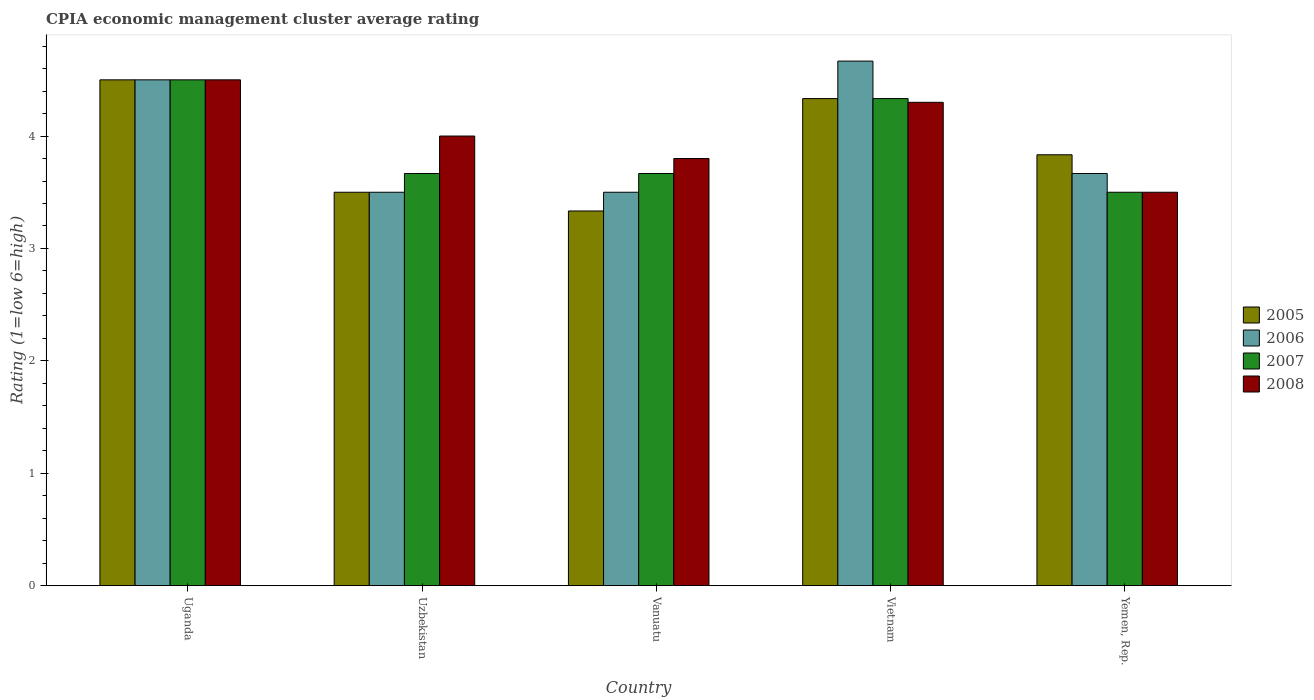How many groups of bars are there?
Offer a terse response. 5. Are the number of bars on each tick of the X-axis equal?
Keep it short and to the point. Yes. What is the label of the 2nd group of bars from the left?
Ensure brevity in your answer.  Uzbekistan. In how many cases, is the number of bars for a given country not equal to the number of legend labels?
Offer a terse response. 0. Across all countries, what is the minimum CPIA rating in 2008?
Provide a short and direct response. 3.5. In which country was the CPIA rating in 2005 maximum?
Keep it short and to the point. Uganda. In which country was the CPIA rating in 2006 minimum?
Give a very brief answer. Uzbekistan. What is the total CPIA rating in 2006 in the graph?
Provide a short and direct response. 19.83. What is the difference between the CPIA rating in 2008 in Vanuatu and the CPIA rating in 2006 in Uganda?
Provide a short and direct response. -0.7. What is the average CPIA rating in 2005 per country?
Provide a succinct answer. 3.9. What is the difference between the CPIA rating of/in 2006 and CPIA rating of/in 2007 in Uzbekistan?
Keep it short and to the point. -0.17. What is the ratio of the CPIA rating in 2005 in Uganda to that in Uzbekistan?
Your answer should be compact. 1.29. Is the difference between the CPIA rating in 2006 in Uganda and Vanuatu greater than the difference between the CPIA rating in 2007 in Uganda and Vanuatu?
Provide a succinct answer. Yes. What is the difference between the highest and the second highest CPIA rating in 2005?
Your answer should be compact. -0.67. What is the difference between the highest and the lowest CPIA rating in 2006?
Keep it short and to the point. 1.17. Is it the case that in every country, the sum of the CPIA rating in 2007 and CPIA rating in 2008 is greater than the sum of CPIA rating in 2005 and CPIA rating in 2006?
Your response must be concise. No. What does the 4th bar from the left in Vanuatu represents?
Your answer should be very brief. 2008. What does the 3rd bar from the right in Uzbekistan represents?
Give a very brief answer. 2006. Is it the case that in every country, the sum of the CPIA rating in 2008 and CPIA rating in 2006 is greater than the CPIA rating in 2005?
Offer a terse response. Yes. Are all the bars in the graph horizontal?
Ensure brevity in your answer.  No. How many countries are there in the graph?
Offer a terse response. 5. What is the difference between two consecutive major ticks on the Y-axis?
Ensure brevity in your answer.  1. How many legend labels are there?
Your answer should be very brief. 4. What is the title of the graph?
Your response must be concise. CPIA economic management cluster average rating. Does "1989" appear as one of the legend labels in the graph?
Offer a terse response. No. What is the label or title of the X-axis?
Your response must be concise. Country. What is the Rating (1=low 6=high) in 2005 in Uganda?
Ensure brevity in your answer.  4.5. What is the Rating (1=low 6=high) in 2006 in Uganda?
Keep it short and to the point. 4.5. What is the Rating (1=low 6=high) of 2007 in Uzbekistan?
Ensure brevity in your answer.  3.67. What is the Rating (1=low 6=high) in 2008 in Uzbekistan?
Make the answer very short. 4. What is the Rating (1=low 6=high) of 2005 in Vanuatu?
Your response must be concise. 3.33. What is the Rating (1=low 6=high) in 2006 in Vanuatu?
Provide a succinct answer. 3.5. What is the Rating (1=low 6=high) of 2007 in Vanuatu?
Keep it short and to the point. 3.67. What is the Rating (1=low 6=high) in 2005 in Vietnam?
Ensure brevity in your answer.  4.33. What is the Rating (1=low 6=high) in 2006 in Vietnam?
Ensure brevity in your answer.  4.67. What is the Rating (1=low 6=high) of 2007 in Vietnam?
Offer a very short reply. 4.33. What is the Rating (1=low 6=high) of 2005 in Yemen, Rep.?
Keep it short and to the point. 3.83. What is the Rating (1=low 6=high) of 2006 in Yemen, Rep.?
Provide a short and direct response. 3.67. What is the Rating (1=low 6=high) in 2008 in Yemen, Rep.?
Offer a terse response. 3.5. Across all countries, what is the maximum Rating (1=low 6=high) in 2005?
Your answer should be compact. 4.5. Across all countries, what is the maximum Rating (1=low 6=high) of 2006?
Make the answer very short. 4.67. Across all countries, what is the maximum Rating (1=low 6=high) in 2007?
Offer a very short reply. 4.5. Across all countries, what is the minimum Rating (1=low 6=high) in 2005?
Your response must be concise. 3.33. Across all countries, what is the minimum Rating (1=low 6=high) in 2007?
Offer a terse response. 3.5. Across all countries, what is the minimum Rating (1=low 6=high) of 2008?
Your answer should be compact. 3.5. What is the total Rating (1=low 6=high) of 2005 in the graph?
Provide a short and direct response. 19.5. What is the total Rating (1=low 6=high) in 2006 in the graph?
Offer a terse response. 19.83. What is the total Rating (1=low 6=high) in 2007 in the graph?
Your answer should be very brief. 19.67. What is the total Rating (1=low 6=high) in 2008 in the graph?
Offer a very short reply. 20.1. What is the difference between the Rating (1=low 6=high) of 2006 in Uganda and that in Uzbekistan?
Offer a very short reply. 1. What is the difference between the Rating (1=low 6=high) of 2008 in Uganda and that in Uzbekistan?
Provide a short and direct response. 0.5. What is the difference between the Rating (1=low 6=high) of 2008 in Uganda and that in Vanuatu?
Keep it short and to the point. 0.7. What is the difference between the Rating (1=low 6=high) of 2007 in Uganda and that in Yemen, Rep.?
Your answer should be compact. 1. What is the difference between the Rating (1=low 6=high) of 2007 in Uzbekistan and that in Vanuatu?
Provide a short and direct response. 0. What is the difference between the Rating (1=low 6=high) in 2008 in Uzbekistan and that in Vanuatu?
Provide a succinct answer. 0.2. What is the difference between the Rating (1=low 6=high) of 2006 in Uzbekistan and that in Vietnam?
Your response must be concise. -1.17. What is the difference between the Rating (1=low 6=high) of 2005 in Uzbekistan and that in Yemen, Rep.?
Keep it short and to the point. -0.33. What is the difference between the Rating (1=low 6=high) of 2005 in Vanuatu and that in Vietnam?
Provide a short and direct response. -1. What is the difference between the Rating (1=low 6=high) of 2006 in Vanuatu and that in Vietnam?
Offer a very short reply. -1.17. What is the difference between the Rating (1=low 6=high) of 2007 in Vanuatu and that in Vietnam?
Your answer should be compact. -0.67. What is the difference between the Rating (1=low 6=high) of 2008 in Vanuatu and that in Vietnam?
Your answer should be very brief. -0.5. What is the difference between the Rating (1=low 6=high) of 2005 in Vanuatu and that in Yemen, Rep.?
Ensure brevity in your answer.  -0.5. What is the difference between the Rating (1=low 6=high) in 2006 in Vanuatu and that in Yemen, Rep.?
Make the answer very short. -0.17. What is the difference between the Rating (1=low 6=high) in 2007 in Vietnam and that in Yemen, Rep.?
Provide a short and direct response. 0.83. What is the difference between the Rating (1=low 6=high) in 2008 in Vietnam and that in Yemen, Rep.?
Provide a short and direct response. 0.8. What is the difference between the Rating (1=low 6=high) of 2005 in Uganda and the Rating (1=low 6=high) of 2007 in Uzbekistan?
Give a very brief answer. 0.83. What is the difference between the Rating (1=low 6=high) of 2005 in Uganda and the Rating (1=low 6=high) of 2008 in Uzbekistan?
Give a very brief answer. 0.5. What is the difference between the Rating (1=low 6=high) of 2006 in Uganda and the Rating (1=low 6=high) of 2007 in Uzbekistan?
Ensure brevity in your answer.  0.83. What is the difference between the Rating (1=low 6=high) of 2006 in Uganda and the Rating (1=low 6=high) of 2008 in Uzbekistan?
Your answer should be compact. 0.5. What is the difference between the Rating (1=low 6=high) in 2005 in Uganda and the Rating (1=low 6=high) in 2008 in Vanuatu?
Ensure brevity in your answer.  0.7. What is the difference between the Rating (1=low 6=high) of 2006 in Uganda and the Rating (1=low 6=high) of 2007 in Vanuatu?
Your answer should be very brief. 0.83. What is the difference between the Rating (1=low 6=high) in 2005 in Uganda and the Rating (1=low 6=high) in 2006 in Yemen, Rep.?
Your answer should be very brief. 0.83. What is the difference between the Rating (1=low 6=high) in 2005 in Uganda and the Rating (1=low 6=high) in 2008 in Yemen, Rep.?
Provide a short and direct response. 1. What is the difference between the Rating (1=low 6=high) in 2007 in Uganda and the Rating (1=low 6=high) in 2008 in Yemen, Rep.?
Ensure brevity in your answer.  1. What is the difference between the Rating (1=low 6=high) of 2005 in Uzbekistan and the Rating (1=low 6=high) of 2006 in Vanuatu?
Your answer should be compact. 0. What is the difference between the Rating (1=low 6=high) of 2005 in Uzbekistan and the Rating (1=low 6=high) of 2007 in Vanuatu?
Your answer should be very brief. -0.17. What is the difference between the Rating (1=low 6=high) of 2006 in Uzbekistan and the Rating (1=low 6=high) of 2007 in Vanuatu?
Provide a succinct answer. -0.17. What is the difference between the Rating (1=low 6=high) of 2007 in Uzbekistan and the Rating (1=low 6=high) of 2008 in Vanuatu?
Offer a terse response. -0.13. What is the difference between the Rating (1=low 6=high) of 2005 in Uzbekistan and the Rating (1=low 6=high) of 2006 in Vietnam?
Offer a terse response. -1.17. What is the difference between the Rating (1=low 6=high) of 2005 in Uzbekistan and the Rating (1=low 6=high) of 2007 in Vietnam?
Ensure brevity in your answer.  -0.83. What is the difference between the Rating (1=low 6=high) in 2006 in Uzbekistan and the Rating (1=low 6=high) in 2008 in Vietnam?
Make the answer very short. -0.8. What is the difference between the Rating (1=low 6=high) in 2007 in Uzbekistan and the Rating (1=low 6=high) in 2008 in Vietnam?
Keep it short and to the point. -0.63. What is the difference between the Rating (1=low 6=high) of 2005 in Uzbekistan and the Rating (1=low 6=high) of 2006 in Yemen, Rep.?
Keep it short and to the point. -0.17. What is the difference between the Rating (1=low 6=high) in 2006 in Uzbekistan and the Rating (1=low 6=high) in 2007 in Yemen, Rep.?
Provide a short and direct response. 0. What is the difference between the Rating (1=low 6=high) of 2007 in Uzbekistan and the Rating (1=low 6=high) of 2008 in Yemen, Rep.?
Offer a terse response. 0.17. What is the difference between the Rating (1=low 6=high) in 2005 in Vanuatu and the Rating (1=low 6=high) in 2006 in Vietnam?
Keep it short and to the point. -1.33. What is the difference between the Rating (1=low 6=high) of 2005 in Vanuatu and the Rating (1=low 6=high) of 2008 in Vietnam?
Provide a short and direct response. -0.97. What is the difference between the Rating (1=low 6=high) in 2007 in Vanuatu and the Rating (1=low 6=high) in 2008 in Vietnam?
Provide a succinct answer. -0.63. What is the difference between the Rating (1=low 6=high) in 2005 in Vanuatu and the Rating (1=low 6=high) in 2006 in Yemen, Rep.?
Offer a very short reply. -0.33. What is the difference between the Rating (1=low 6=high) of 2005 in Vanuatu and the Rating (1=low 6=high) of 2008 in Yemen, Rep.?
Provide a succinct answer. -0.17. What is the difference between the Rating (1=low 6=high) of 2006 in Vanuatu and the Rating (1=low 6=high) of 2008 in Yemen, Rep.?
Your answer should be very brief. 0. What is the difference between the Rating (1=low 6=high) in 2005 in Vietnam and the Rating (1=low 6=high) in 2006 in Yemen, Rep.?
Offer a very short reply. 0.67. What is the difference between the Rating (1=low 6=high) in 2005 in Vietnam and the Rating (1=low 6=high) in 2007 in Yemen, Rep.?
Your answer should be compact. 0.83. What is the difference between the Rating (1=low 6=high) of 2006 in Vietnam and the Rating (1=low 6=high) of 2007 in Yemen, Rep.?
Offer a very short reply. 1.17. What is the difference between the Rating (1=low 6=high) of 2006 in Vietnam and the Rating (1=low 6=high) of 2008 in Yemen, Rep.?
Offer a very short reply. 1.17. What is the difference between the Rating (1=low 6=high) of 2007 in Vietnam and the Rating (1=low 6=high) of 2008 in Yemen, Rep.?
Your answer should be very brief. 0.83. What is the average Rating (1=low 6=high) in 2006 per country?
Provide a short and direct response. 3.97. What is the average Rating (1=low 6=high) of 2007 per country?
Ensure brevity in your answer.  3.93. What is the average Rating (1=low 6=high) of 2008 per country?
Your answer should be very brief. 4.02. What is the difference between the Rating (1=low 6=high) of 2005 and Rating (1=low 6=high) of 2008 in Uganda?
Offer a terse response. 0. What is the difference between the Rating (1=low 6=high) of 2005 and Rating (1=low 6=high) of 2007 in Uzbekistan?
Provide a succinct answer. -0.17. What is the difference between the Rating (1=low 6=high) of 2007 and Rating (1=low 6=high) of 2008 in Uzbekistan?
Provide a succinct answer. -0.33. What is the difference between the Rating (1=low 6=high) in 2005 and Rating (1=low 6=high) in 2006 in Vanuatu?
Offer a very short reply. -0.17. What is the difference between the Rating (1=low 6=high) in 2005 and Rating (1=low 6=high) in 2007 in Vanuatu?
Provide a succinct answer. -0.33. What is the difference between the Rating (1=low 6=high) of 2005 and Rating (1=low 6=high) of 2008 in Vanuatu?
Your answer should be compact. -0.47. What is the difference between the Rating (1=low 6=high) in 2007 and Rating (1=low 6=high) in 2008 in Vanuatu?
Offer a terse response. -0.13. What is the difference between the Rating (1=low 6=high) of 2006 and Rating (1=low 6=high) of 2008 in Vietnam?
Ensure brevity in your answer.  0.37. What is the difference between the Rating (1=low 6=high) in 2007 and Rating (1=low 6=high) in 2008 in Yemen, Rep.?
Provide a succinct answer. 0. What is the ratio of the Rating (1=low 6=high) in 2006 in Uganda to that in Uzbekistan?
Offer a terse response. 1.29. What is the ratio of the Rating (1=low 6=high) in 2007 in Uganda to that in Uzbekistan?
Offer a very short reply. 1.23. What is the ratio of the Rating (1=low 6=high) in 2005 in Uganda to that in Vanuatu?
Provide a succinct answer. 1.35. What is the ratio of the Rating (1=low 6=high) in 2006 in Uganda to that in Vanuatu?
Keep it short and to the point. 1.29. What is the ratio of the Rating (1=low 6=high) of 2007 in Uganda to that in Vanuatu?
Give a very brief answer. 1.23. What is the ratio of the Rating (1=low 6=high) in 2008 in Uganda to that in Vanuatu?
Your response must be concise. 1.18. What is the ratio of the Rating (1=low 6=high) in 2005 in Uganda to that in Vietnam?
Offer a very short reply. 1.04. What is the ratio of the Rating (1=low 6=high) in 2006 in Uganda to that in Vietnam?
Offer a very short reply. 0.96. What is the ratio of the Rating (1=low 6=high) in 2007 in Uganda to that in Vietnam?
Your answer should be very brief. 1.04. What is the ratio of the Rating (1=low 6=high) in 2008 in Uganda to that in Vietnam?
Ensure brevity in your answer.  1.05. What is the ratio of the Rating (1=low 6=high) in 2005 in Uganda to that in Yemen, Rep.?
Make the answer very short. 1.17. What is the ratio of the Rating (1=low 6=high) in 2006 in Uganda to that in Yemen, Rep.?
Ensure brevity in your answer.  1.23. What is the ratio of the Rating (1=low 6=high) in 2007 in Uganda to that in Yemen, Rep.?
Your answer should be very brief. 1.29. What is the ratio of the Rating (1=low 6=high) of 2006 in Uzbekistan to that in Vanuatu?
Provide a succinct answer. 1. What is the ratio of the Rating (1=low 6=high) in 2007 in Uzbekistan to that in Vanuatu?
Your response must be concise. 1. What is the ratio of the Rating (1=low 6=high) in 2008 in Uzbekistan to that in Vanuatu?
Keep it short and to the point. 1.05. What is the ratio of the Rating (1=low 6=high) of 2005 in Uzbekistan to that in Vietnam?
Provide a succinct answer. 0.81. What is the ratio of the Rating (1=low 6=high) of 2006 in Uzbekistan to that in Vietnam?
Ensure brevity in your answer.  0.75. What is the ratio of the Rating (1=low 6=high) in 2007 in Uzbekistan to that in Vietnam?
Keep it short and to the point. 0.85. What is the ratio of the Rating (1=low 6=high) in 2008 in Uzbekistan to that in Vietnam?
Provide a short and direct response. 0.93. What is the ratio of the Rating (1=low 6=high) of 2006 in Uzbekistan to that in Yemen, Rep.?
Make the answer very short. 0.95. What is the ratio of the Rating (1=low 6=high) in 2007 in Uzbekistan to that in Yemen, Rep.?
Keep it short and to the point. 1.05. What is the ratio of the Rating (1=low 6=high) of 2005 in Vanuatu to that in Vietnam?
Give a very brief answer. 0.77. What is the ratio of the Rating (1=low 6=high) of 2006 in Vanuatu to that in Vietnam?
Provide a short and direct response. 0.75. What is the ratio of the Rating (1=low 6=high) in 2007 in Vanuatu to that in Vietnam?
Offer a terse response. 0.85. What is the ratio of the Rating (1=low 6=high) in 2008 in Vanuatu to that in Vietnam?
Ensure brevity in your answer.  0.88. What is the ratio of the Rating (1=low 6=high) in 2005 in Vanuatu to that in Yemen, Rep.?
Make the answer very short. 0.87. What is the ratio of the Rating (1=low 6=high) in 2006 in Vanuatu to that in Yemen, Rep.?
Give a very brief answer. 0.95. What is the ratio of the Rating (1=low 6=high) in 2007 in Vanuatu to that in Yemen, Rep.?
Offer a very short reply. 1.05. What is the ratio of the Rating (1=low 6=high) in 2008 in Vanuatu to that in Yemen, Rep.?
Offer a terse response. 1.09. What is the ratio of the Rating (1=low 6=high) of 2005 in Vietnam to that in Yemen, Rep.?
Your response must be concise. 1.13. What is the ratio of the Rating (1=low 6=high) in 2006 in Vietnam to that in Yemen, Rep.?
Keep it short and to the point. 1.27. What is the ratio of the Rating (1=low 6=high) in 2007 in Vietnam to that in Yemen, Rep.?
Your answer should be very brief. 1.24. What is the ratio of the Rating (1=low 6=high) in 2008 in Vietnam to that in Yemen, Rep.?
Your answer should be very brief. 1.23. What is the difference between the highest and the second highest Rating (1=low 6=high) in 2005?
Offer a very short reply. 0.17. What is the difference between the highest and the second highest Rating (1=low 6=high) of 2007?
Your response must be concise. 0.17. What is the difference between the highest and the second highest Rating (1=low 6=high) in 2008?
Keep it short and to the point. 0.2. What is the difference between the highest and the lowest Rating (1=low 6=high) in 2005?
Your answer should be compact. 1.17. What is the difference between the highest and the lowest Rating (1=low 6=high) of 2007?
Ensure brevity in your answer.  1. What is the difference between the highest and the lowest Rating (1=low 6=high) of 2008?
Your answer should be compact. 1. 